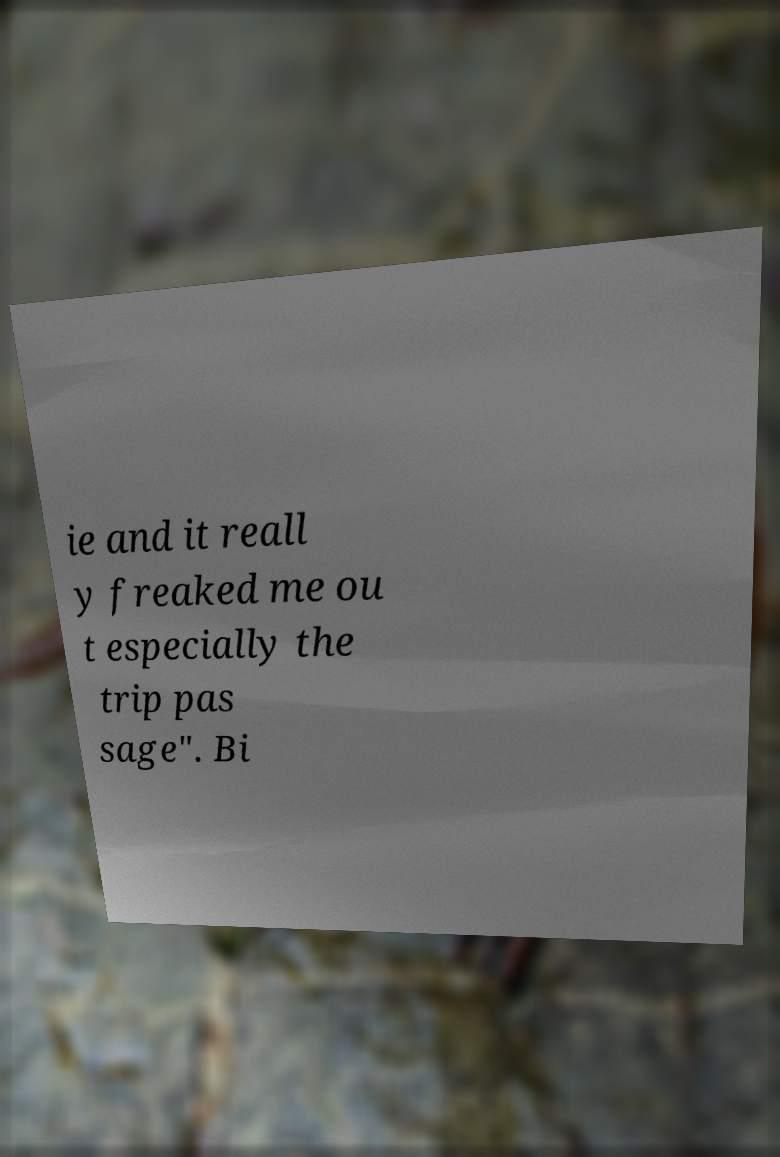Can you accurately transcribe the text from the provided image for me? ie and it reall y freaked me ou t especially the trip pas sage". Bi 